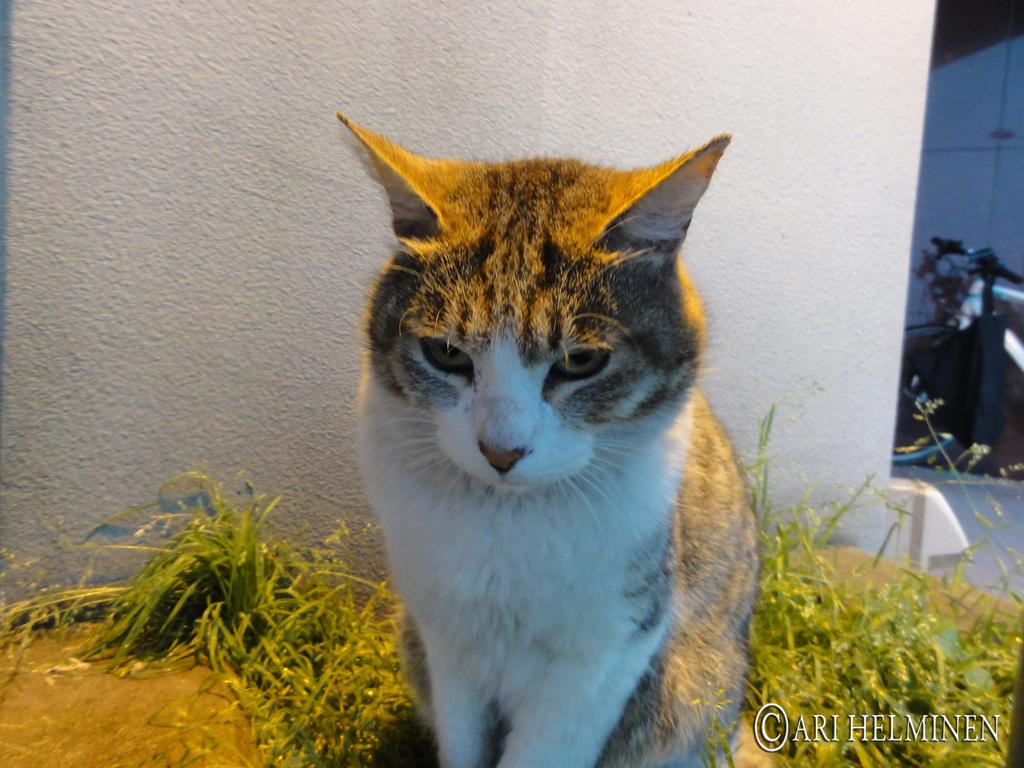What type of animal is present in the image? There is a cat in the image. What type of vegetation can be seen in the image? There is grass in the image. What type of structure is visible in the image? There is a wall in the image. What can be seen on the ground in the background of the image? There is an object on the ground in the background of the image. What is the name of the cat in the image? The name of the cat is not mentioned in the image, so it cannot be determined. 